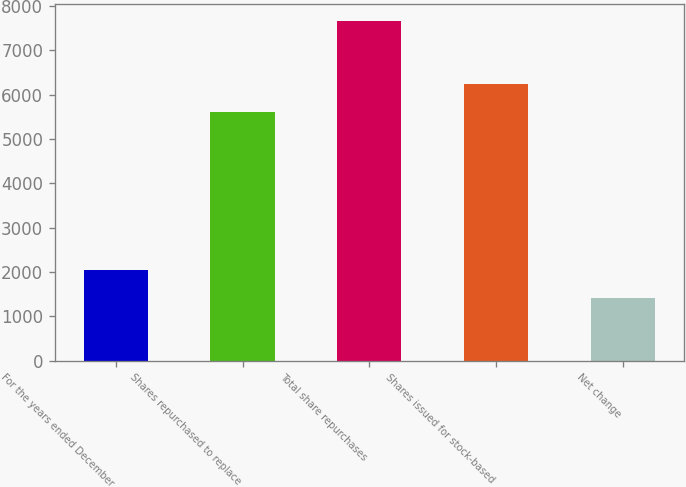<chart> <loc_0><loc_0><loc_500><loc_500><bar_chart><fcel>For the years ended December<fcel>Shares repurchased to replace<fcel>Total share repurchases<fcel>Shares issued for stock-based<fcel>Net change<nl><fcel>2043.3<fcel>5599<fcel>7653<fcel>6233<fcel>1420<nl></chart> 